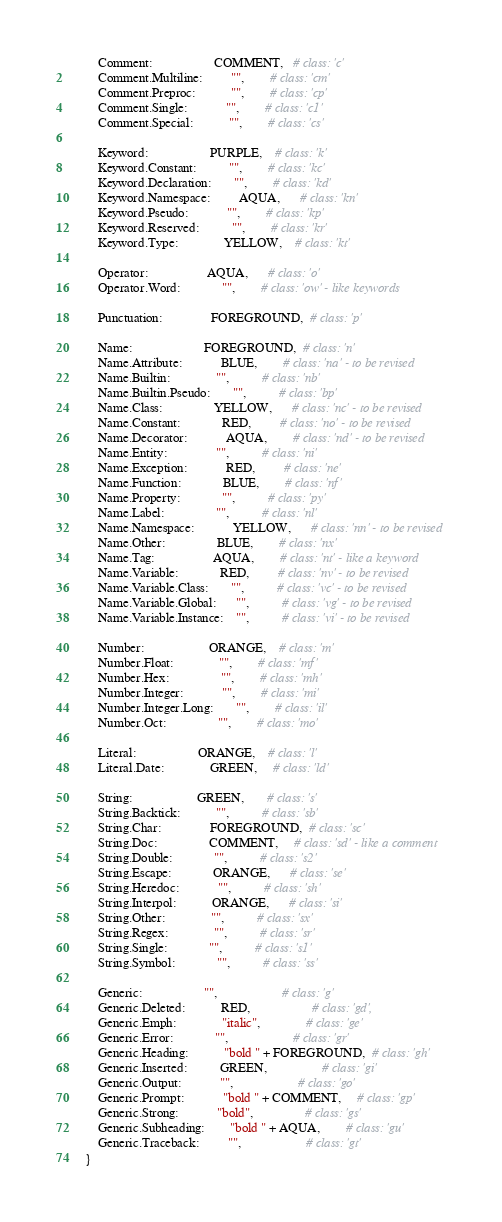<code> <loc_0><loc_0><loc_500><loc_500><_Python_>
        Comment:                   COMMENT,   # class: 'c'
        Comment.Multiline:         "",        # class: 'cm'
        Comment.Preproc:           "",        # class: 'cp'
        Comment.Single:            "",        # class: 'c1'
        Comment.Special:           "",        # class: 'cs'

        Keyword:                   PURPLE,    # class: 'k'
        Keyword.Constant:          "",        # class: 'kc'
        Keyword.Declaration:       "",        # class: 'kd'
        Keyword.Namespace:         AQUA,      # class: 'kn'
        Keyword.Pseudo:            "",        # class: 'kp'
        Keyword.Reserved:          "",        # class: 'kr'
        Keyword.Type:              YELLOW,    # class: 'kt'

        Operator:                  AQUA,      # class: 'o'
        Operator.Word:             "",        # class: 'ow' - like keywords

        Punctuation:               FOREGROUND,  # class: 'p'

        Name:                      FOREGROUND,  # class: 'n'
        Name.Attribute:            BLUE,        # class: 'na' - to be revised
        Name.Builtin:              "",          # class: 'nb'
        Name.Builtin.Pseudo:       "",          # class: 'bp'
        Name.Class:                YELLOW,      # class: 'nc' - to be revised
        Name.Constant:             RED,         # class: 'no' - to be revised
        Name.Decorator:            AQUA,        # class: 'nd' - to be revised
        Name.Entity:               "",          # class: 'ni'
        Name.Exception:            RED,         # class: 'ne'
        Name.Function:             BLUE,        # class: 'nf'
        Name.Property:             "",          # class: 'py'
        Name.Label:                "",          # class: 'nl'
        Name.Namespace:            YELLOW,      # class: 'nn' - to be revised
        Name.Other:                BLUE,        # class: 'nx'
        Name.Tag:                  AQUA,        # class: 'nt' - like a keyword
        Name.Variable:             RED,         # class: 'nv' - to be revised
        Name.Variable.Class:       "",          # class: 'vc' - to be revised
        Name.Variable.Global:      "",          # class: 'vg' - to be revised
        Name.Variable.Instance:    "",          # class: 'vi' - to be revised

        Number:                    ORANGE,    # class: 'm'
        Number.Float:              "",        # class: 'mf'
        Number.Hex:                "",        # class: 'mh'
        Number.Integer:            "",        # class: 'mi'
        Number.Integer.Long:       "",        # class: 'il'
        Number.Oct:                "",        # class: 'mo'

        Literal:                   ORANGE,    # class: 'l'
        Literal.Date:              GREEN,     # class: 'ld'

        String:                    GREEN,       # class: 's'
        String.Backtick:           "",          # class: 'sb'
        String.Char:               FOREGROUND,  # class: 'sc'
        String.Doc:                COMMENT,     # class: 'sd' - like a comment
        String.Double:             "",          # class: 's2'
        String.Escape:             ORANGE,      # class: 'se'
        String.Heredoc:            "",          # class: 'sh'
        String.Interpol:           ORANGE,      # class: 'si'
        String.Other:              "",          # class: 'sx'
        String.Regex:              "",          # class: 'sr'
        String.Single:             "",          # class: 's1'
        String.Symbol:             "",          # class: 'ss'

        Generic:                   "",                    # class: 'g'
        Generic.Deleted:           RED,                   # class: 'gd',
        Generic.Emph:              "italic",              # class: 'ge'
        Generic.Error:             "",                    # class: 'gr'
        Generic.Heading:           "bold " + FOREGROUND,  # class: 'gh'
        Generic.Inserted:          GREEN,                 # class: 'gi'
        Generic.Output:            "",                    # class: 'go'
        Generic.Prompt:            "bold " + COMMENT,     # class: 'gp'
        Generic.Strong:            "bold",                # class: 'gs'
        Generic.Subheading:        "bold " + AQUA,        # class: 'gu'
        Generic.Traceback:         "",                    # class: 'gt'
    }
</code> 